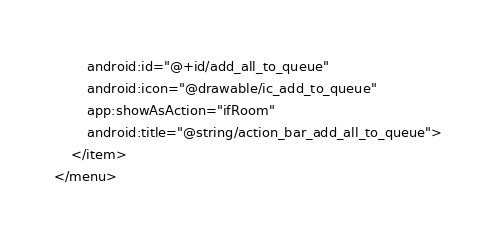Convert code to text. <code><loc_0><loc_0><loc_500><loc_500><_XML_>        android:id="@+id/add_all_to_queue"
        android:icon="@drawable/ic_add_to_queue"
        app:showAsAction="ifRoom"
        android:title="@string/action_bar_add_all_to_queue">
    </item>
</menu></code> 